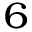Convert formula to latex. <formula><loc_0><loc_0><loc_500><loc_500>_ { 6 }</formula> 